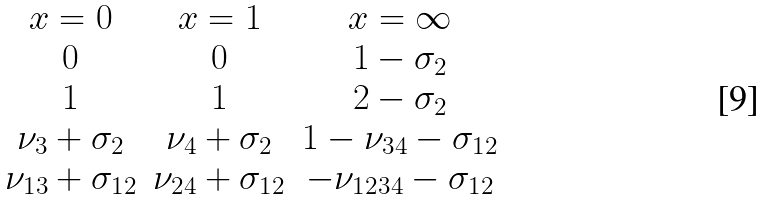<formula> <loc_0><loc_0><loc_500><loc_500>\begin{matrix} x = 0 & x = 1 & x = \infty \\ 0 & 0 & 1 - \sigma _ { 2 } \\ 1 & 1 & 2 - \sigma _ { 2 } \\ \nu _ { 3 } + \sigma _ { 2 } & \nu _ { 4 } + \sigma _ { 2 } & 1 - \nu _ { 3 4 } - \sigma _ { 1 2 } \\ \nu _ { 1 3 } + \sigma _ { 1 2 } & \nu _ { 2 4 } + \sigma _ { 1 2 } & - \nu _ { 1 2 3 4 } - \sigma _ { 1 2 } \end{matrix}</formula> 